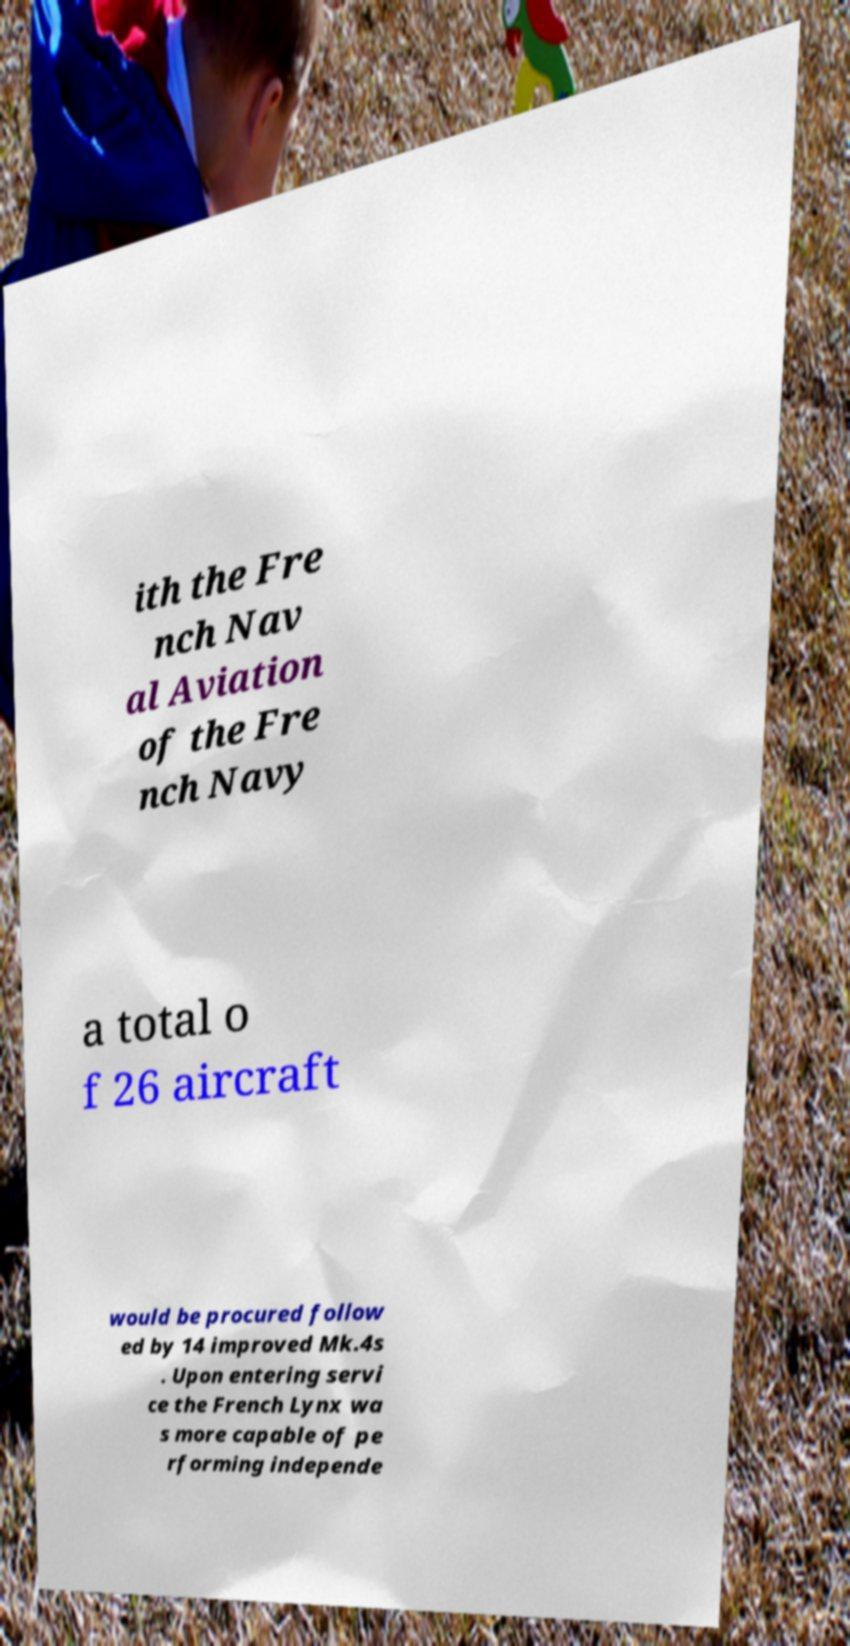What messages or text are displayed in this image? I need them in a readable, typed format. ith the Fre nch Nav al Aviation of the Fre nch Navy a total o f 26 aircraft would be procured follow ed by 14 improved Mk.4s . Upon entering servi ce the French Lynx wa s more capable of pe rforming independe 